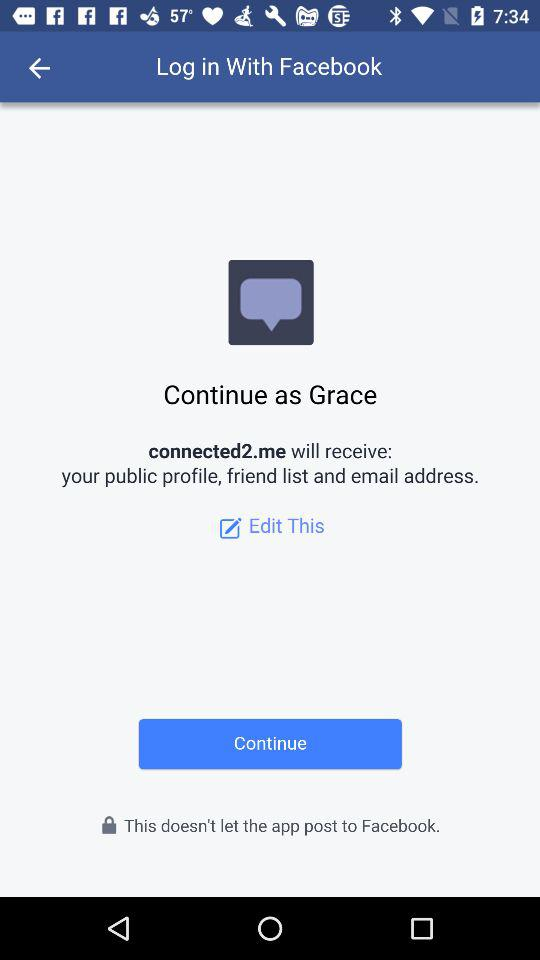Which information will connected2.me receive? The information that will be received by connected2.me is: public profile, friend list, and email address. 